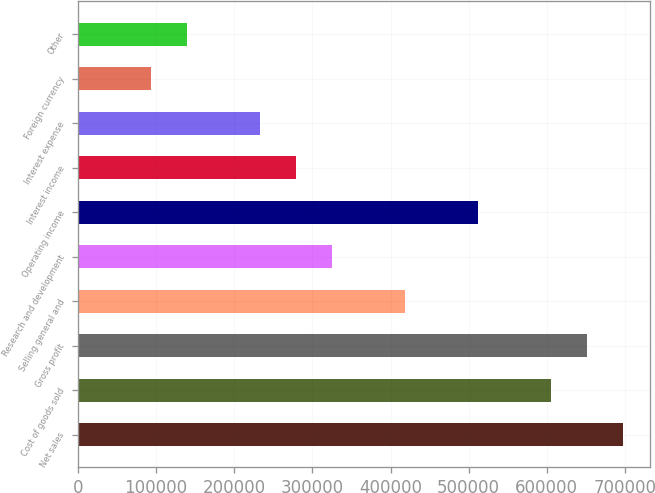<chart> <loc_0><loc_0><loc_500><loc_500><bar_chart><fcel>Net sales<fcel>Cost of goods sold<fcel>Gross profit<fcel>Selling general and<fcel>Research and development<fcel>Operating income<fcel>Interest income<fcel>Interest expense<fcel>Foreign currency<fcel>Other<nl><fcel>697715<fcel>604687<fcel>651201<fcel>418630<fcel>325601<fcel>511658<fcel>279087<fcel>232573<fcel>93029.9<fcel>139544<nl></chart> 